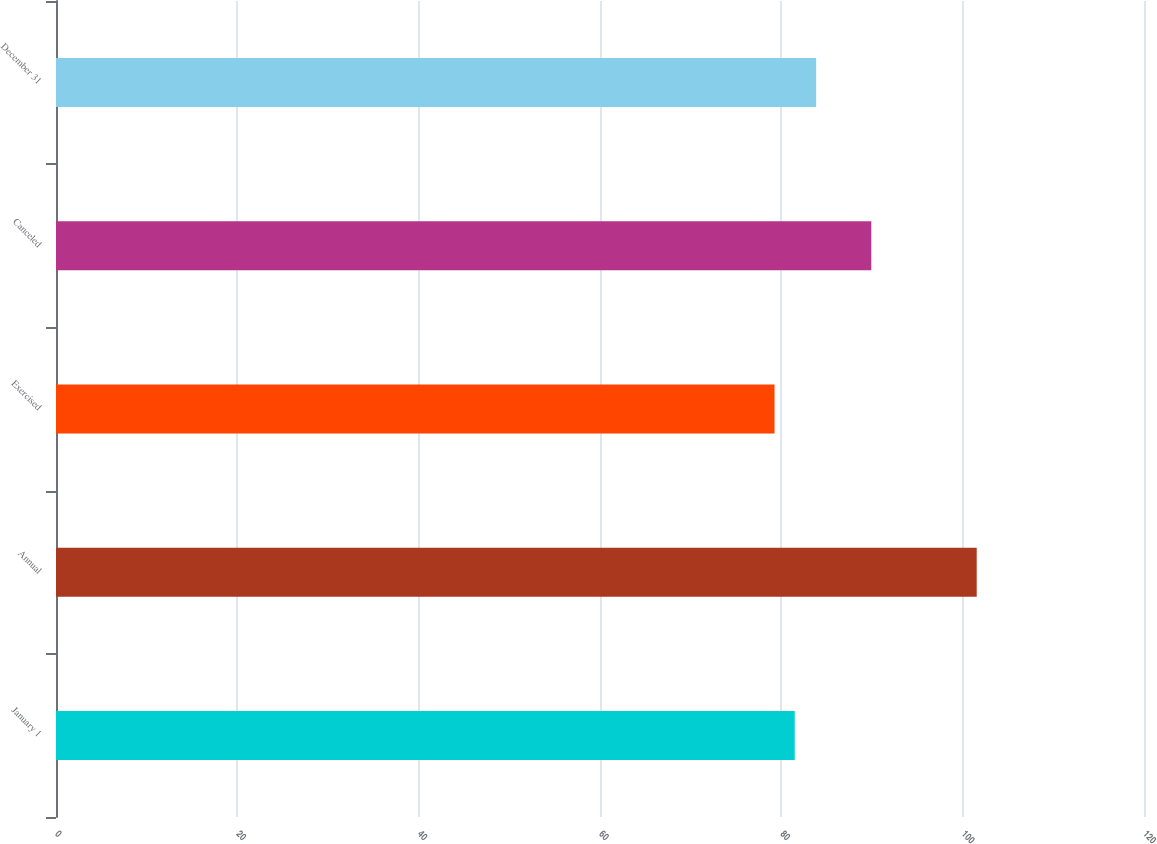Convert chart. <chart><loc_0><loc_0><loc_500><loc_500><bar_chart><fcel>January 1<fcel>Annual<fcel>Exercised<fcel>Canceled<fcel>December 31<nl><fcel>81.48<fcel>101.55<fcel>79.25<fcel>89.92<fcel>83.84<nl></chart> 